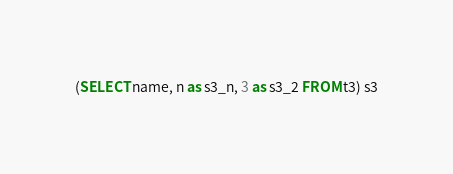<code> <loc_0><loc_0><loc_500><loc_500><_SQL_>(SELECT name, n as s3_n, 3 as s3_2 FROM t3) s3
</code> 